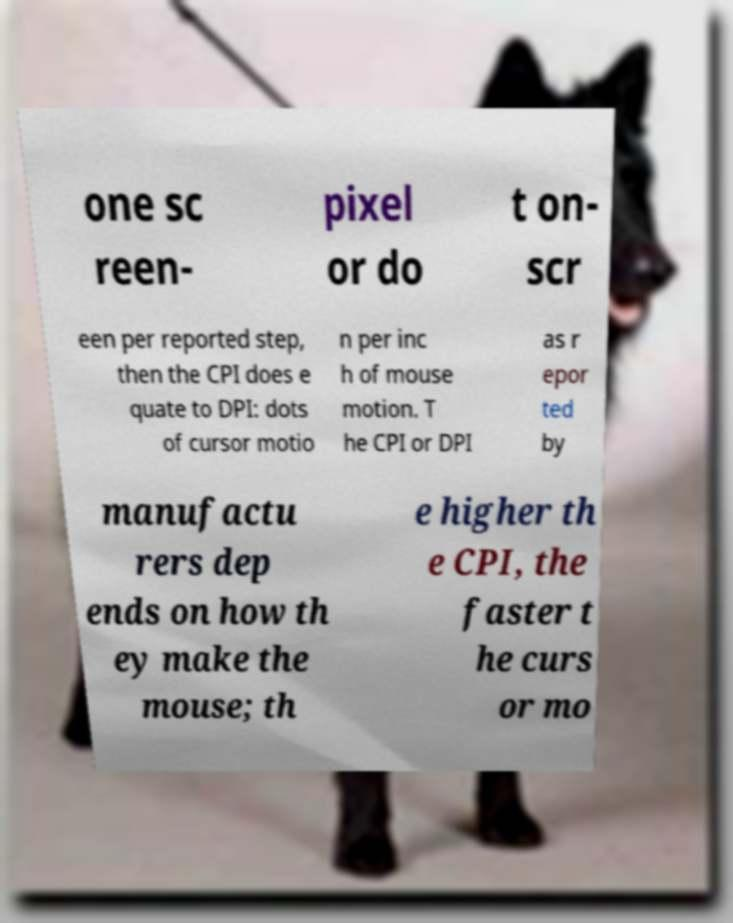For documentation purposes, I need the text within this image transcribed. Could you provide that? one sc reen- pixel or do t on- scr een per reported step, then the CPI does e quate to DPI: dots of cursor motio n per inc h of mouse motion. T he CPI or DPI as r epor ted by manufactu rers dep ends on how th ey make the mouse; th e higher th e CPI, the faster t he curs or mo 